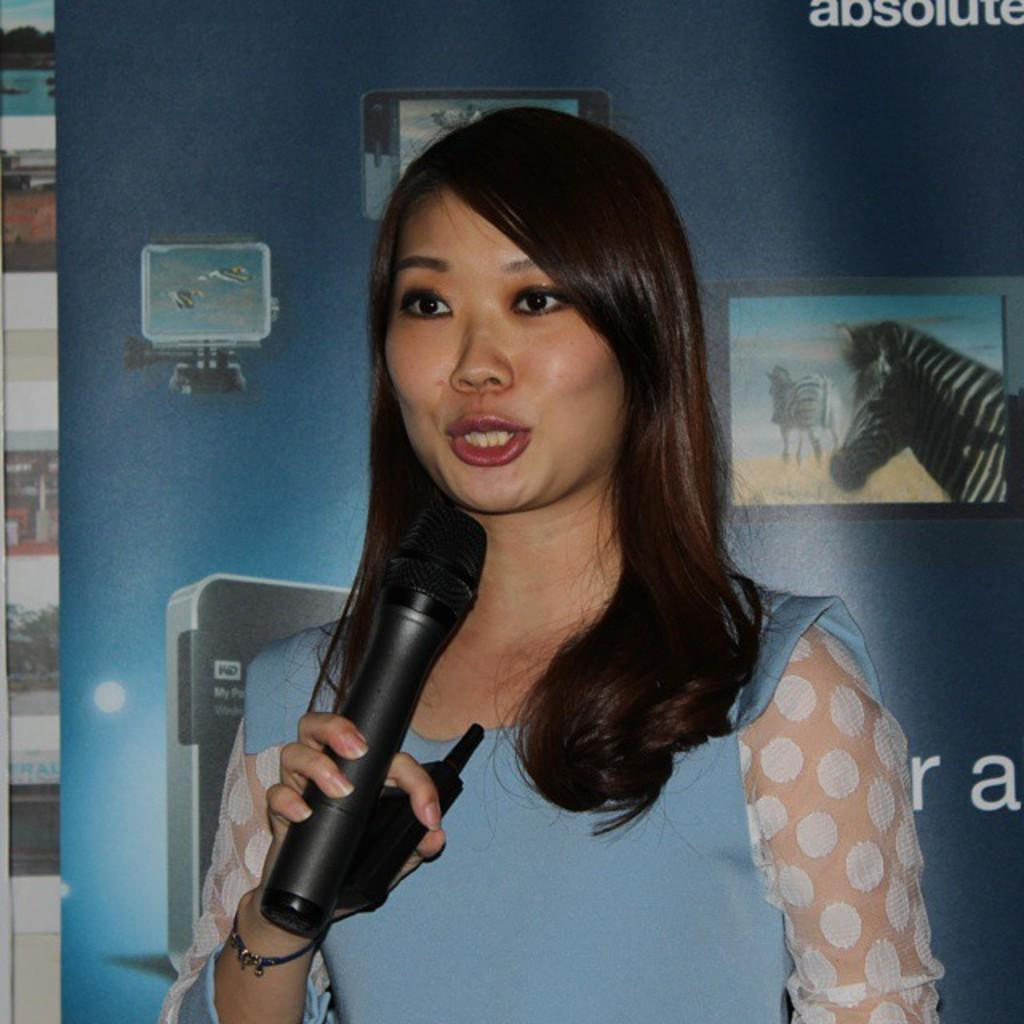Who is the main subject in the image? There is a woman in the image. What is the woman holding in her hand? The woman is holding a microphone in her hand. What type of sweater is the woman wearing in the image? The image does not show the woman wearing a sweater, so it cannot be determined from the image. 